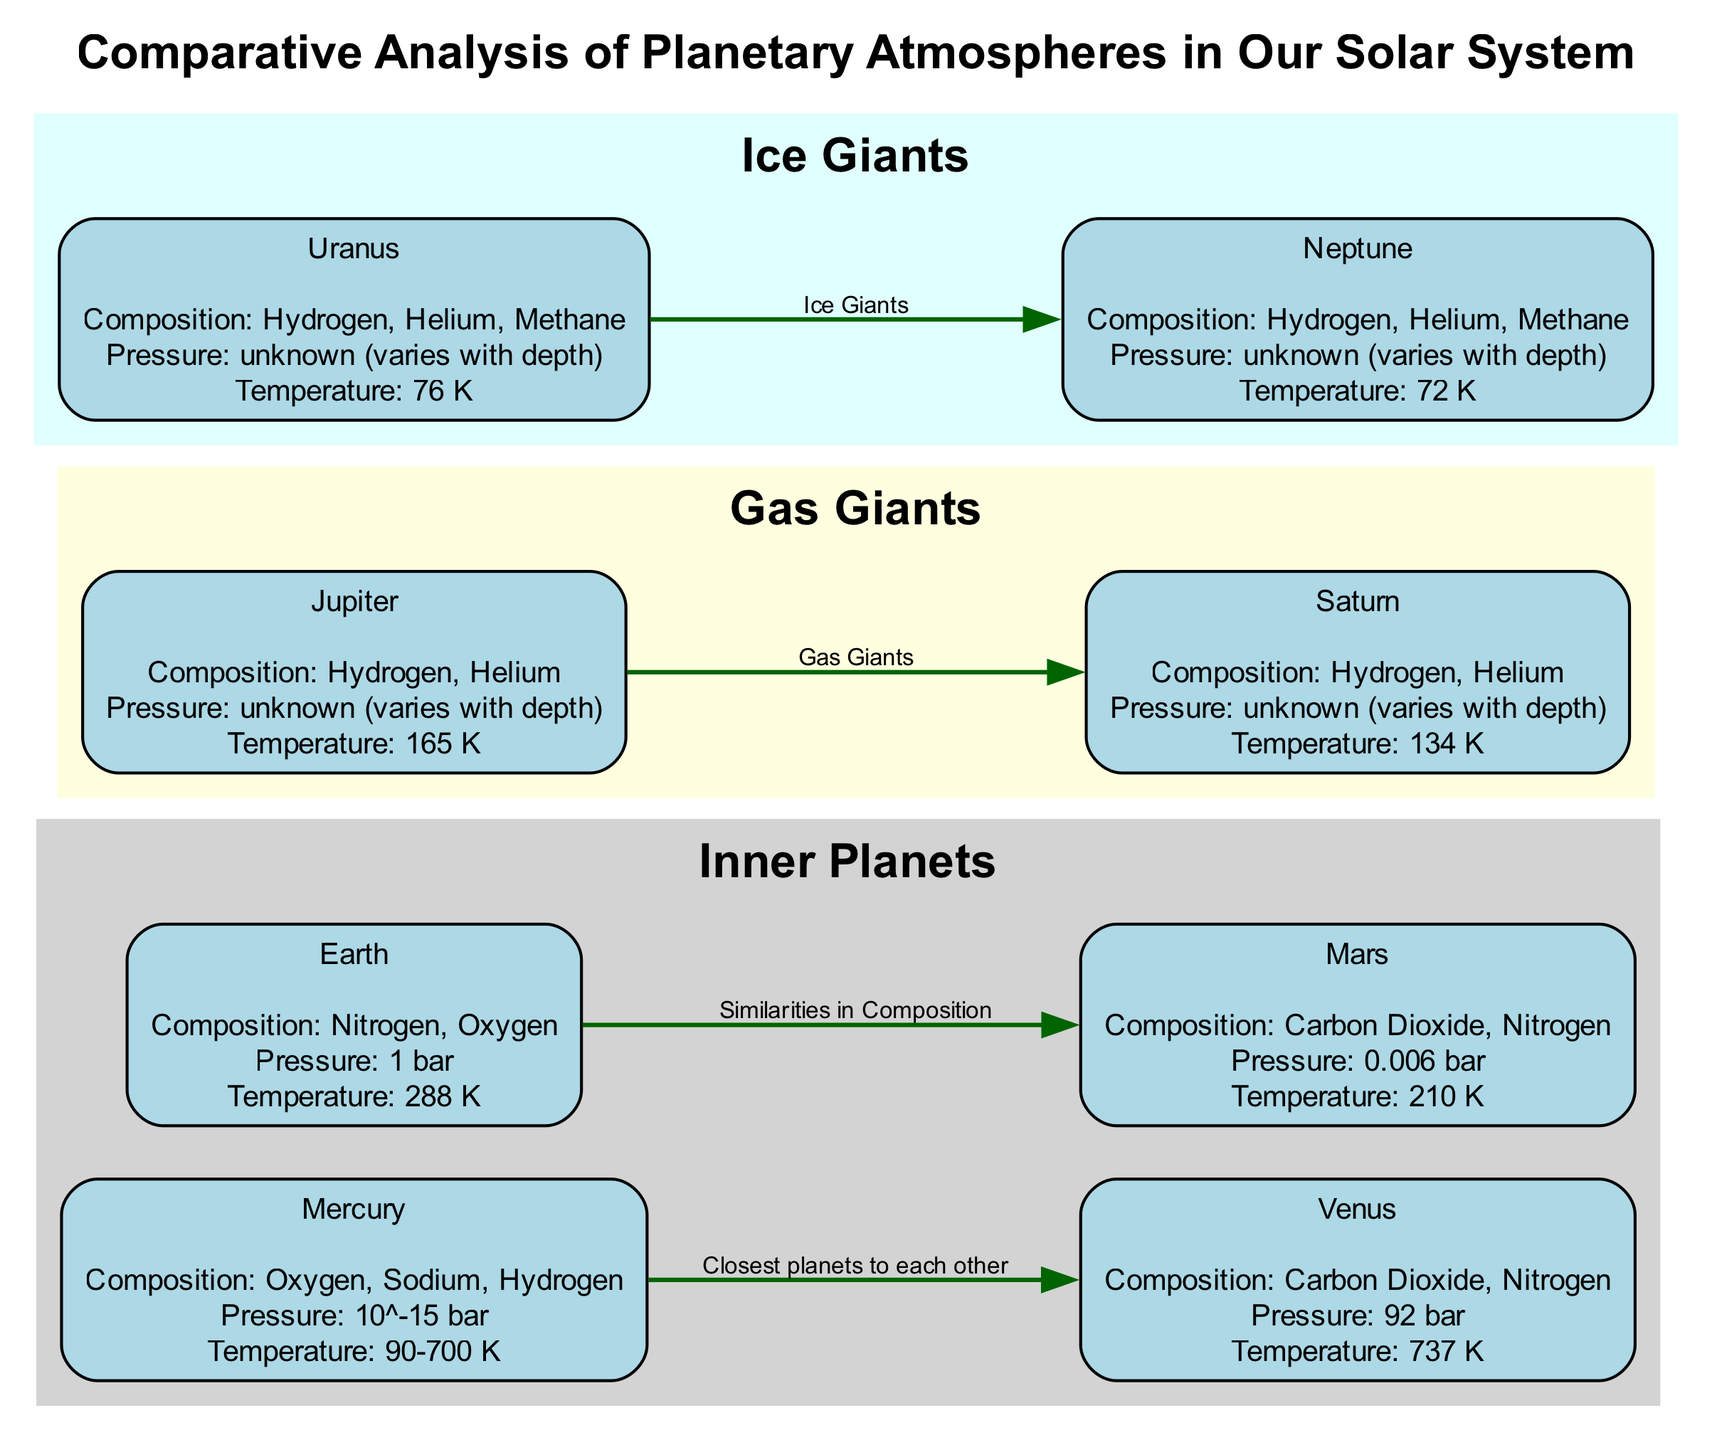What is the pressure on Venus? The diagram lists Venus's pressure as "92 bar." Since it is a direct piece of information provided in the description of Venus, I can simply extract that value.
Answer: 92 bar Which planet has the highest temperature? By reviewing the temperature values presented for all the planets, Venus has the highest temperature at "737 K." I compare each temperature after identifying all the values.
Answer: 737 K How many planets have a composition that includes Hydrogen? The diagram specifies the compositions of each planet. Mercury, Jupiter, Saturn, Uranus, and Neptune all include Hydrogen. Counting these gives me a total of five planets.
Answer: 5 Which two planets are gas giants? The diagram identifies Jupiter and Saturn as gas giants, and the label connecting them emphasizes their classification. I locate these planets in the diagram to determine which fit this category.
Answer: Jupiter and Saturn What is the temperature range of Mercury? Mercury's temperature is listed as "90-700 K" in the diagram. This indicates a range, so I report it as is, directly from the information provided.
Answer: 90-700 K Which planet has a composition similar to Mars? The diagram indicates that Mars has a composition of "Carbon Dioxide, Nitrogen," and Earth shares similar constituents. Thus, I look for Earth in the diagram, noting its similar composition.
Answer: Earth What is the pressure on Mars? The diagram clearly states the pressure on Mars as "0.006 bar." I can directly answer by extracting this numeric value from the information provided about Mars.
Answer: 0.006 bar How are Uranus and Neptune classified in the diagram? The diagram explicitly labels both Uranus and Neptune as "Ice Giants." I reference the labeling sections in the diagram for this classification to respond accurately.
Answer: Ice Giants Which two planets are identified as closest to each other in the diagram? The diagram connects Mercury and Venus with a labeled edge stating "Closest planets to each other." This specific labeling provides a straightforward answer about their relationship.
Answer: Mercury and Venus 